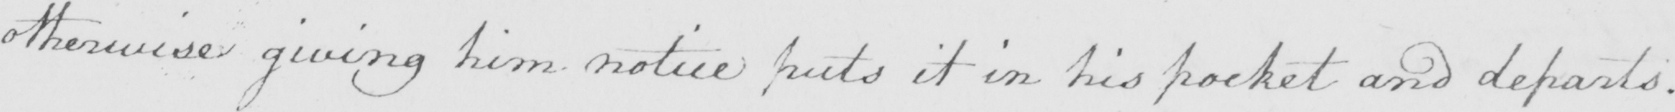What is written in this line of handwriting? otherwise giving him notice puts it in his pocket and departs . 